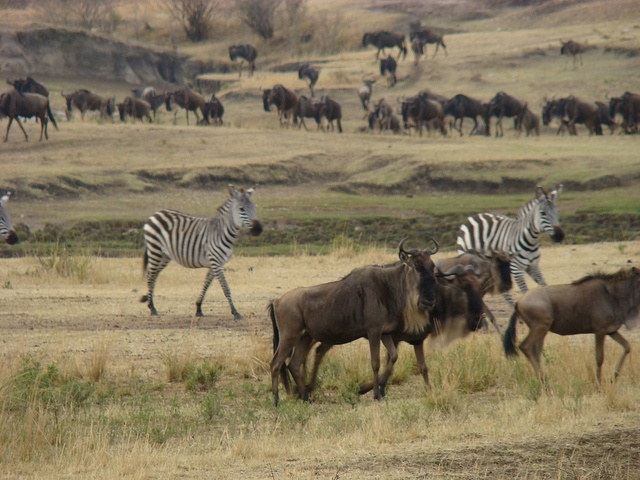Describe the objects in this image and their specific colors. I can see zebra in gray and darkgray tones and zebra in gray and darkgray tones in this image. 